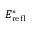Convert formula to latex. <formula><loc_0><loc_0><loc_500><loc_500>E _ { r e f l } ^ { * }</formula> 